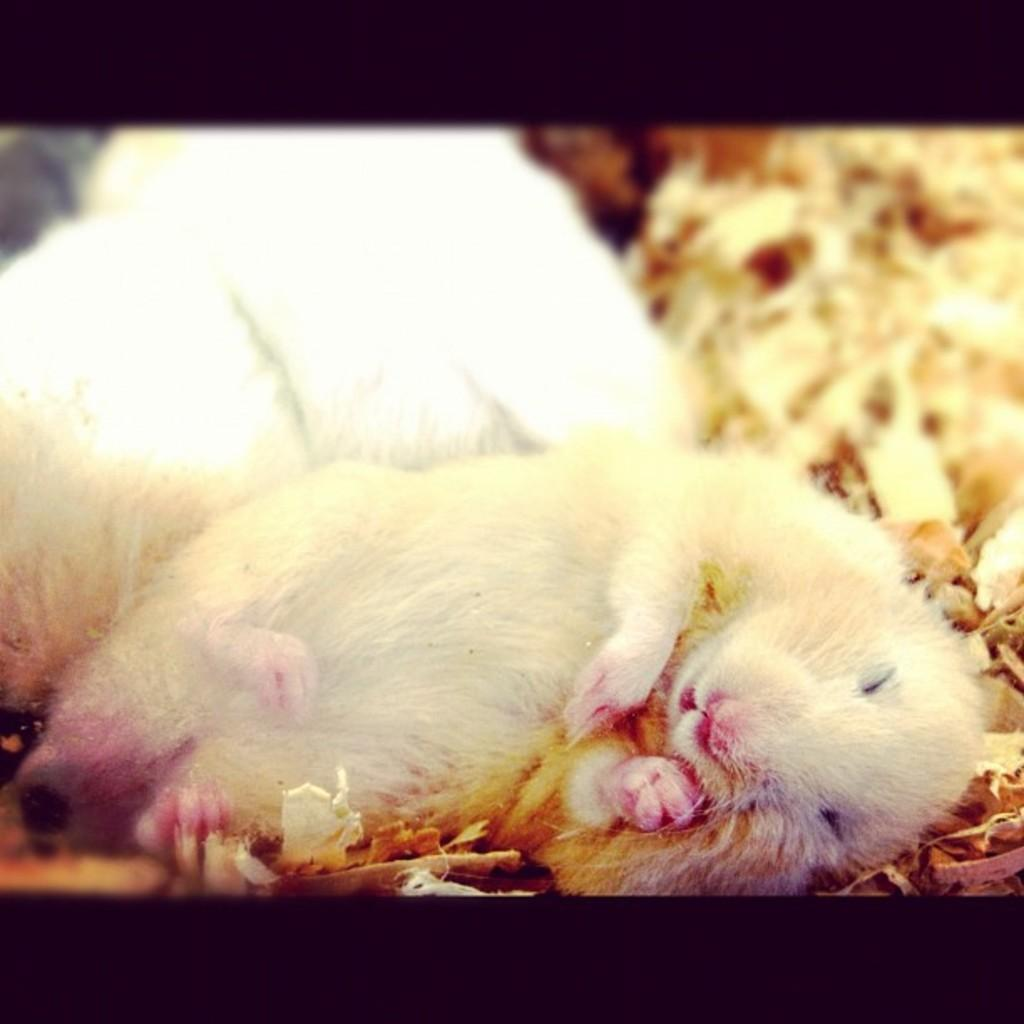What animals are present in the image? There are two rats in the image. What else can be seen in the image besides the rats? There are some objects in the image. Can you describe the background of the image? The background of the image is blurred. Are there any specific design elements in the image? Yes, there are black borders at the top and bottom of the image. How does the rat start the fire in the image? There is no fire present in the image, and the rats do not start any fires. 